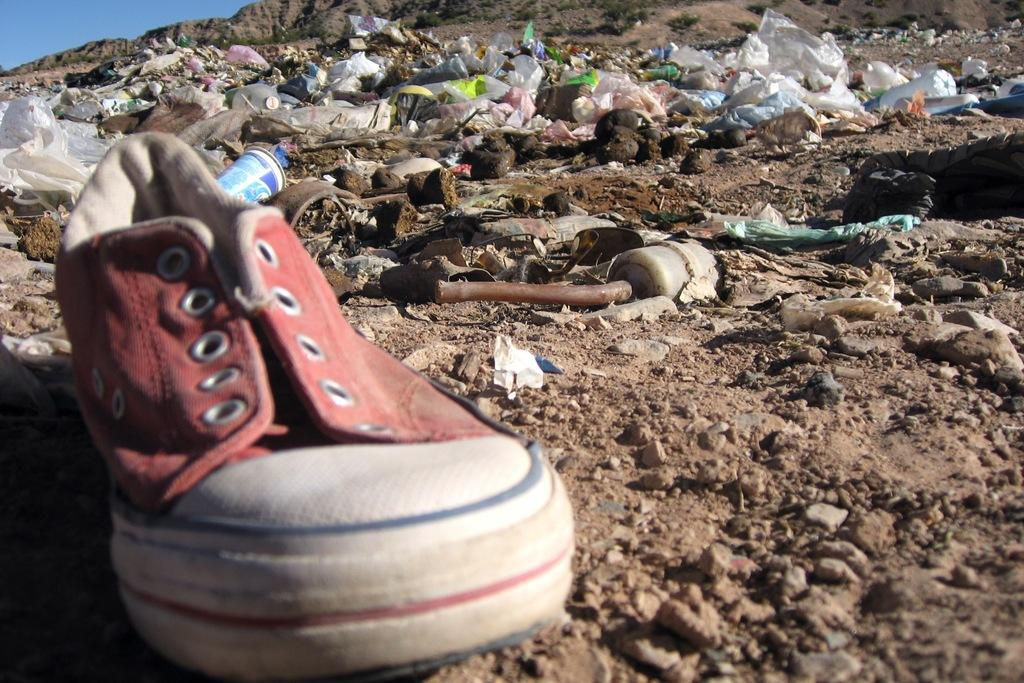What objects are on the ground in the image? There are covers, a cup, and a shoe on the ground in the image. What is the condition of these objects? The items on the ground appear to be trash. What color is the sky in the image? The sky is blue in the image. Can you see the father playing with a bee in the image? There is no father or bee present in the image. What season is depicted in the image based on the presence of falling leaves? There is no mention of leaves falling in the image, and the provided facts do not indicate a specific season. 